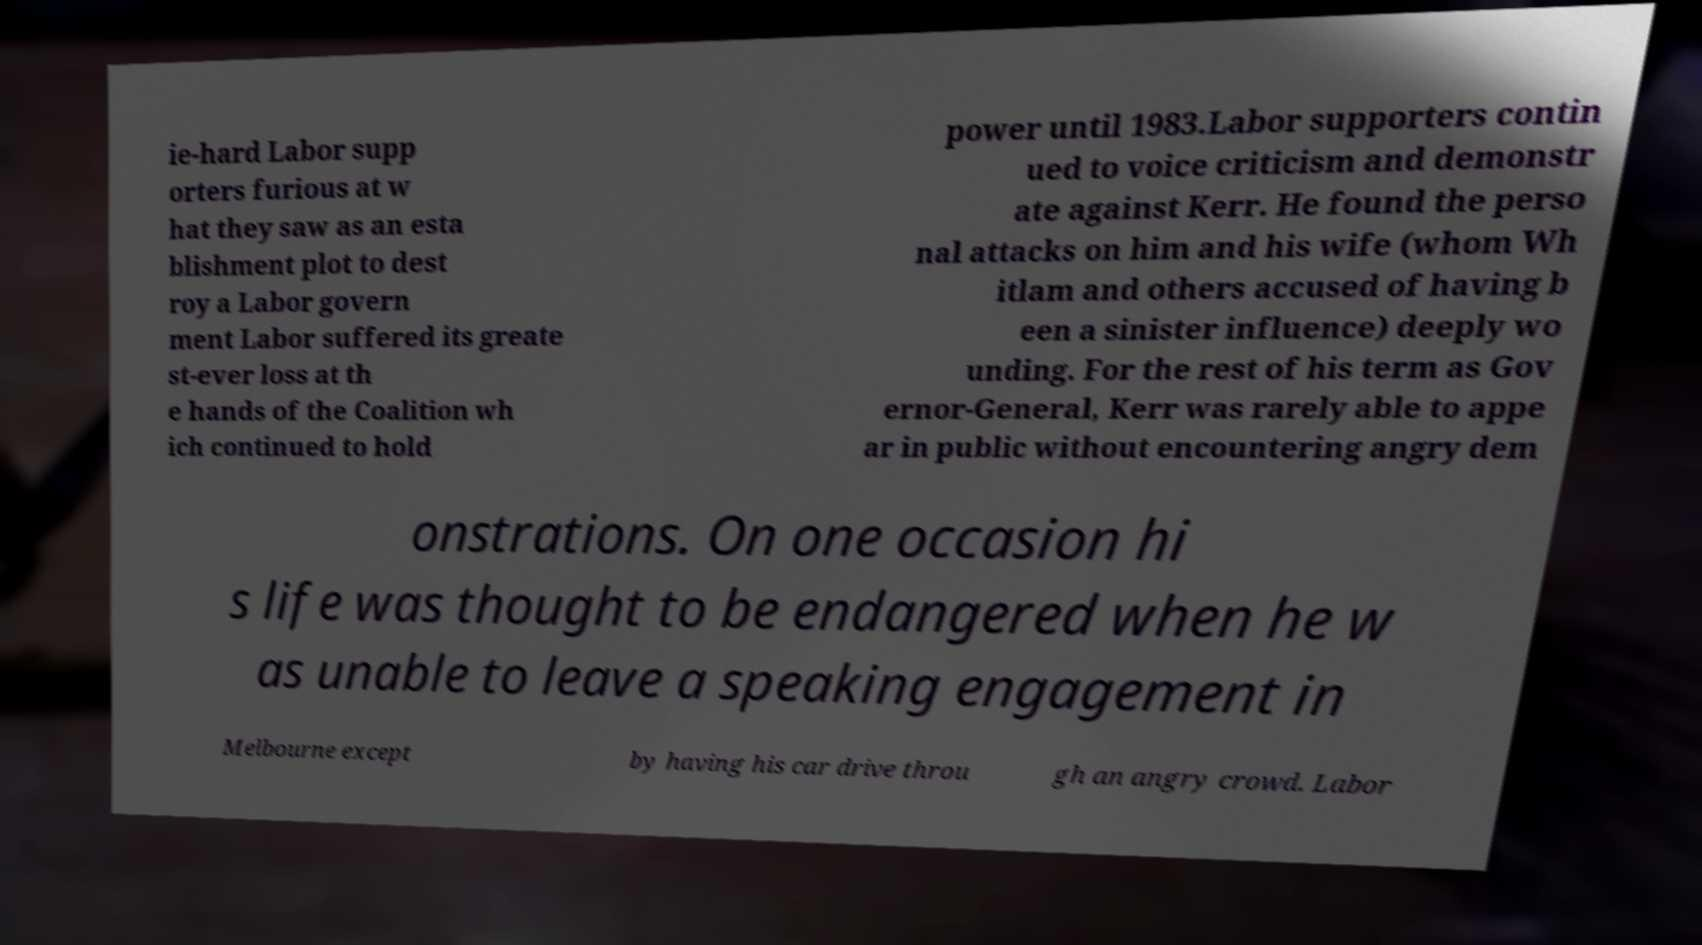Please read and relay the text visible in this image. What does it say? ie-hard Labor supp orters furious at w hat they saw as an esta blishment plot to dest roy a Labor govern ment Labor suffered its greate st-ever loss at th e hands of the Coalition wh ich continued to hold power until 1983.Labor supporters contin ued to voice criticism and demonstr ate against Kerr. He found the perso nal attacks on him and his wife (whom Wh itlam and others accused of having b een a sinister influence) deeply wo unding. For the rest of his term as Gov ernor-General, Kerr was rarely able to appe ar in public without encountering angry dem onstrations. On one occasion hi s life was thought to be endangered when he w as unable to leave a speaking engagement in Melbourne except by having his car drive throu gh an angry crowd. Labor 